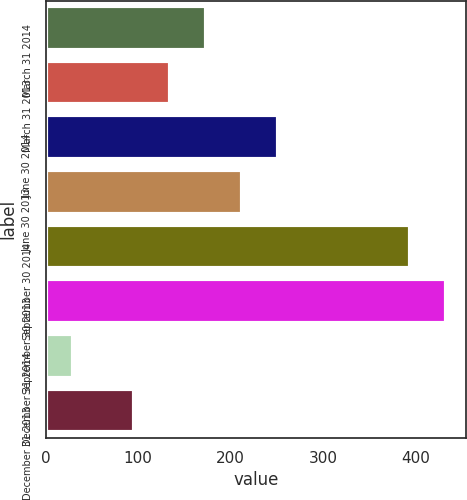Convert chart to OTSL. <chart><loc_0><loc_0><loc_500><loc_500><bar_chart><fcel>March 31 2014<fcel>March 31 2013<fcel>June 30 2014<fcel>June 30 2013<fcel>September 30 2014<fcel>September 30 2013<fcel>December 31 2014<fcel>December 31 2013<nl><fcel>173.6<fcel>134.8<fcel>251.2<fcel>212.4<fcel>394<fcel>432.8<fcel>29<fcel>96<nl></chart> 